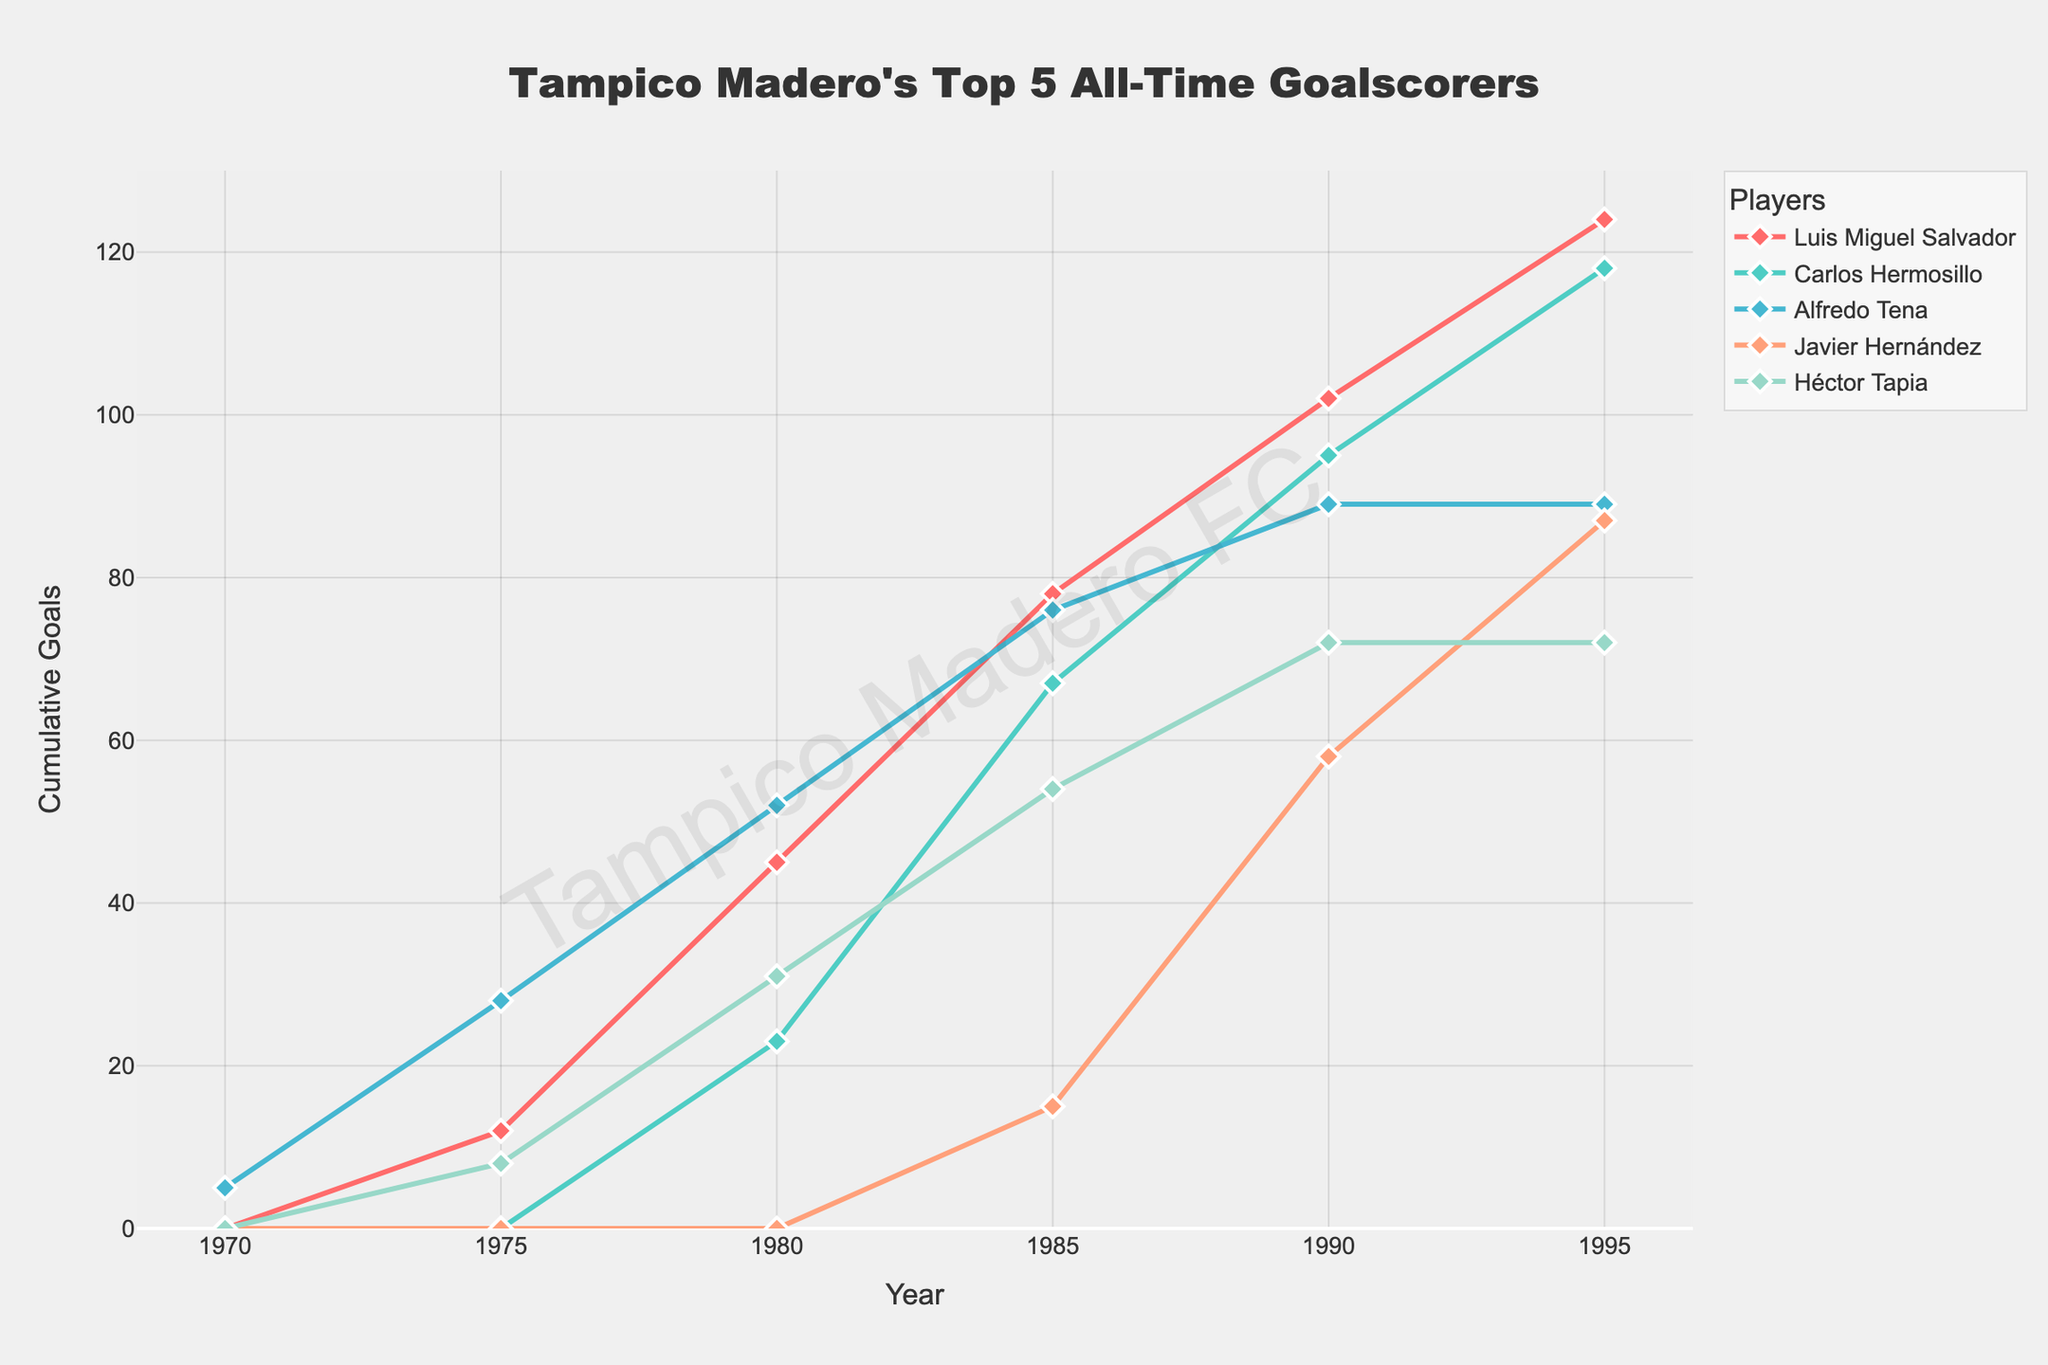Which player scored the most goals by 1995? Look at the 1995 data point and compare Luis Miguel Salvador (124), Carlos Hermosillo (118), Alfredo Tena (89), Javier Hernández (87), and Héctor Tapia (72).
Answer: Luis Miguel Salvador How many goals did Javier Hernández score between 1985 and 1995? Subtract the number of goals in 1985 (15) from the number of goals in 1995 (87) for Javier Hernández.
Answer: 72 Which player had a faster increase in total goals between 1980 and 1985? Compare the slope of the lines for each player between 1980 and 1985. Luis Miguel Salvador (33), Carlos Hermosillo (44), Alfredo Tena (24), Javier Hernández (15), and Héctor Tapia (23). The steepest line indicates the fastest increase.
Answer: Luis Miguel Salvador At which year did Alfredo Tena's goal count stop increasing? Identify the year when Alfredo Tena's line becomes flat; it stops at 1990 with a goal count of 89.
Answer: 1990 What is the average number of goals scored by the top 5 players in 1995? Add the goals scored by all players in 1995 (124 + 118 + 89 + 87 + 72) and divide by 5.
Answer: 98 How does Héctor Tapia's cumulative goals in 1980 compare to 1990? Compare the data points for Héctor Tapia in 1980 (31) and 1990 (72).
Answer: Higher in 1990 Who scored fewer goals in 1975, Luis Miguel Salvador or Héctor Tapia? Compare the number of goals for Luis Miguel Salvador (12) and Héctor Tapia (8) in 1975.
Answer: Héctor Tapia Which player's goal count remained the same between two periods, 1990 and 1995? Check each player's goal counts in 1990 and 1995. Alfredo Tena's count is 89 for both years.
Answer: Alfredo Tena How many more goals did Luis Miguel Salvador score than Carlos Hermosillo by 1985? Subtract Carlos Hermosillo's total goals in 1985 (67) from Luis Miguel Salvador's total in 1985 (78).
Answer: 11 Between 1985 and 1990, which player had the smallest increase in goals? Calculate the difference in goals between 1985 and 1990 for each player. Carlos Hermosillo (28), Luis Miguel Salvador (24), Javier Hernández (43), Alfredo Tena (13), Héctor Tapia (18). The smallest increase is Alfredo Tena.
Answer: Alfredo Tena 